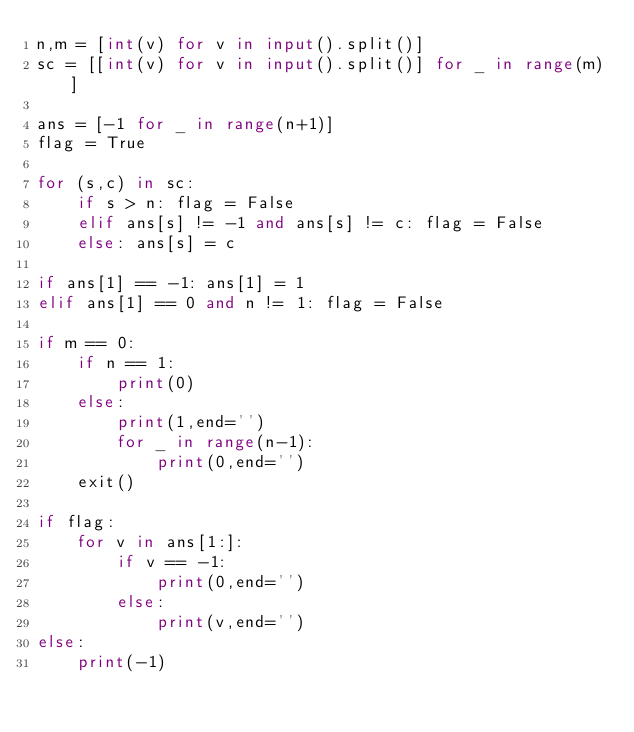<code> <loc_0><loc_0><loc_500><loc_500><_Python_>n,m = [int(v) for v in input().split()]
sc = [[int(v) for v in input().split()] for _ in range(m)]

ans = [-1 for _ in range(n+1)]
flag = True

for (s,c) in sc:
    if s > n: flag = False
    elif ans[s] != -1 and ans[s] != c: flag = False
    else: ans[s] = c

if ans[1] == -1: ans[1] = 1
elif ans[1] == 0 and n != 1: flag = False

if m == 0:
    if n == 1:
        print(0)
    else:
        print(1,end='')
        for _ in range(n-1):
            print(0,end='')
    exit()

if flag:
    for v in ans[1:]:
        if v == -1:
            print(0,end='')
        else:
            print(v,end='')
else:
    print(-1)
</code> 